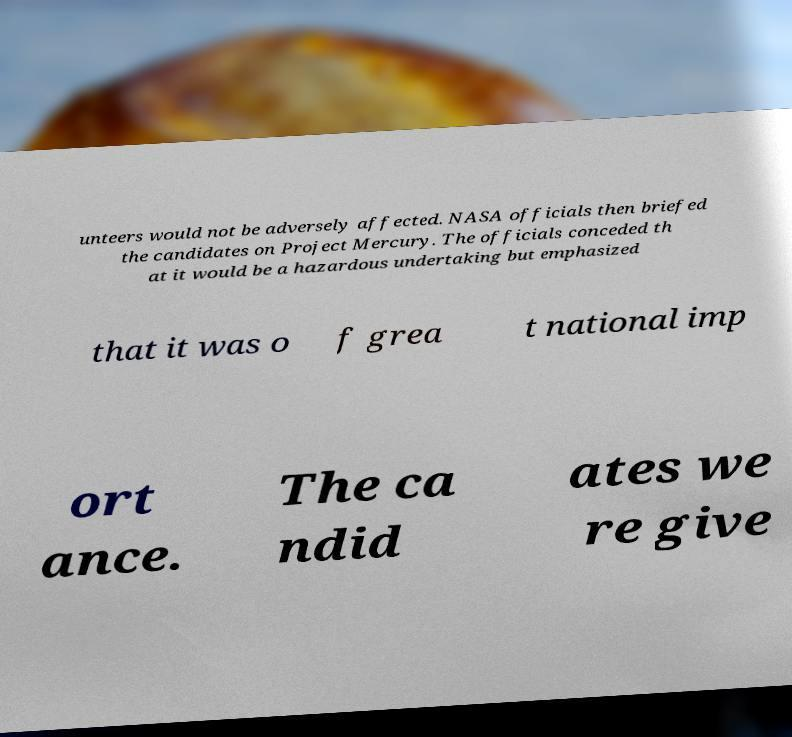Can you read and provide the text displayed in the image?This photo seems to have some interesting text. Can you extract and type it out for me? unteers would not be adversely affected. NASA officials then briefed the candidates on Project Mercury. The officials conceded th at it would be a hazardous undertaking but emphasized that it was o f grea t national imp ort ance. The ca ndid ates we re give 